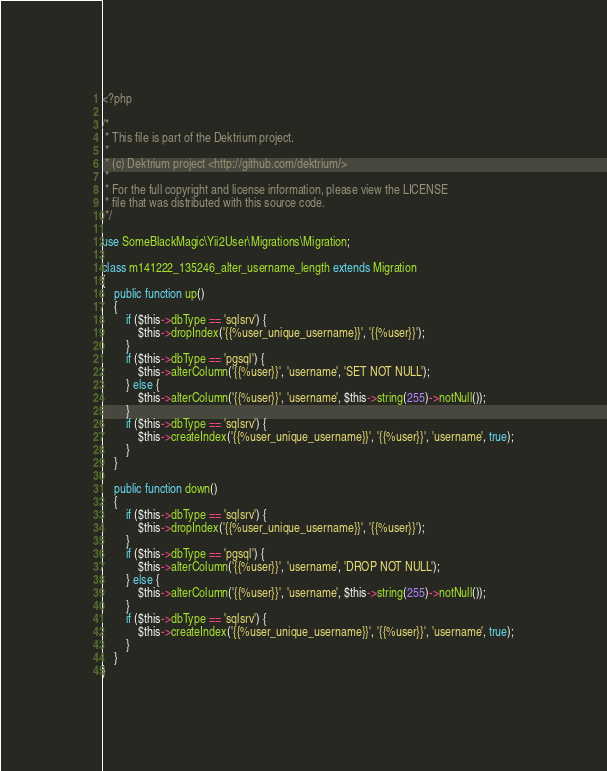Convert code to text. <code><loc_0><loc_0><loc_500><loc_500><_PHP_><?php

/*
 * This file is part of the Dektrium project.
 *
 * (c) Dektrium project <http://github.com/dektrium/>
 *
 * For the full copyright and license information, please view the LICENSE
 * file that was distributed with this source code.
 */

use SomeBlackMagic\Yii2User\Migrations\Migration;

class m141222_135246_alter_username_length extends Migration
{
    public function up()
    {
        if ($this->dbType == 'sqlsrv') {
            $this->dropIndex('{{%user_unique_username}}', '{{%user}}');
        }
        if ($this->dbType == 'pgsql') {
            $this->alterColumn('{{%user}}', 'username', 'SET NOT NULL');
        } else {
            $this->alterColumn('{{%user}}', 'username', $this->string(255)->notNull());
        }
        if ($this->dbType == 'sqlsrv') {
            $this->createIndex('{{%user_unique_username}}', '{{%user}}', 'username', true);
        }
    }

    public function down()
    {
        if ($this->dbType == 'sqlsrv') {
            $this->dropIndex('{{%user_unique_username}}', '{{%user}}');
        }
        if ($this->dbType == 'pgsql') {
            $this->alterColumn('{{%user}}', 'username', 'DROP NOT NULL');
        } else {
            $this->alterColumn('{{%user}}', 'username', $this->string(255)->notNull());
        }
        if ($this->dbType == 'sqlsrv') {
            $this->createIndex('{{%user_unique_username}}', '{{%user}}', 'username', true);
        }
    }
}
</code> 